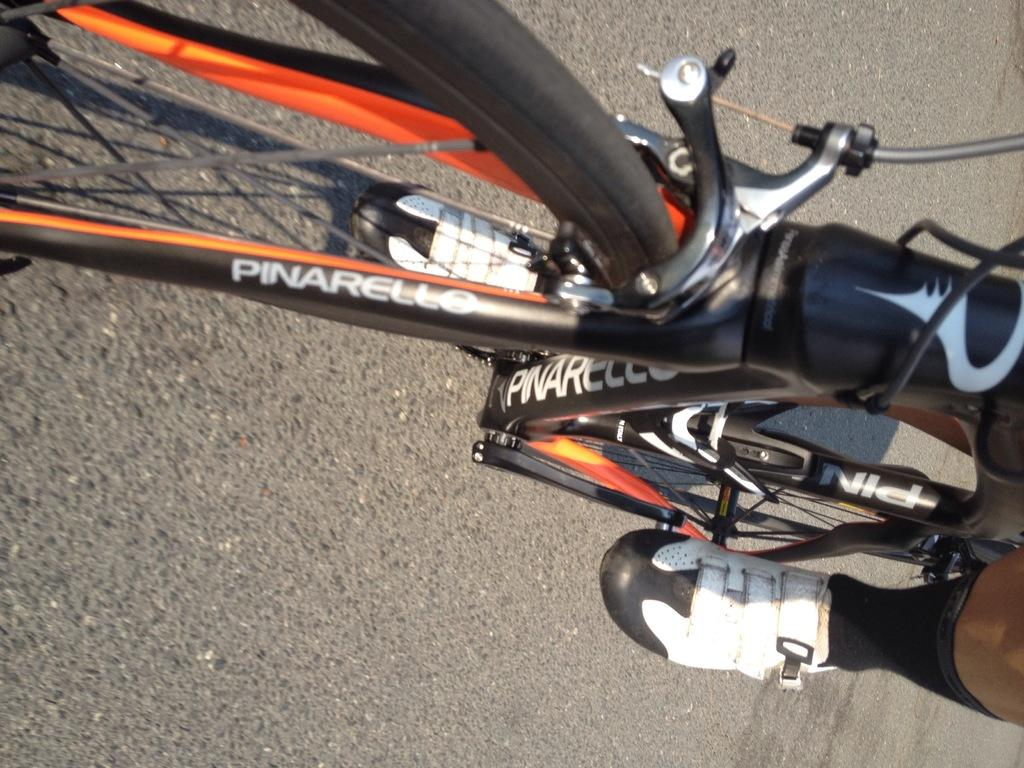What is the main subject of the image? The main subject of the image is a bicycle. What is the person on the bicycle doing? A person is riding the bicycle. Can you describe the position of the person's leg in the image? The person's leg is visible in the bottom right of the image. Where is the bicycle located? The bicycle is on a road. What type of writing can be seen on the person's veil in the image? There is no veil or writing present in the image. 